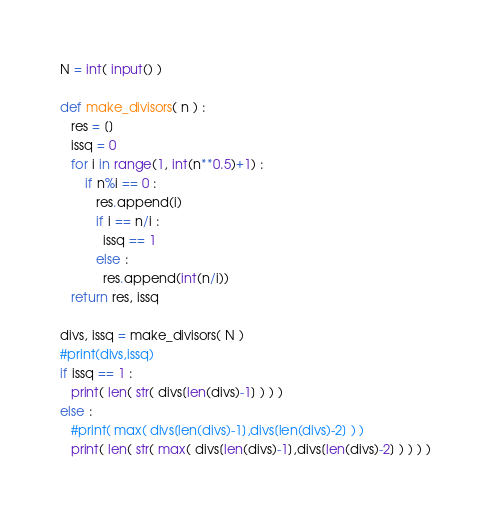Convert code to text. <code><loc_0><loc_0><loc_500><loc_500><_Python_>N = int( input() )

def make_divisors( n ) :
   res = []
   issq = 0
   for i in range(1, int(n**0.5)+1) :
       if n%i == 0 :
          res.append(i)
          if i == n/i :
            issq == 1
          else :
            res.append(int(n/i))
   return res, issq

divs, issq = make_divisors( N )
#print(divs,issq)
if issq == 1 :
   print( len( str( divs[len(divs)-1] ) ) )
else :
   #print( max( divs[len(divs)-1],divs[len(divs)-2] ) )
   print( len( str( max( divs[len(divs)-1],divs[len(divs)-2] ) ) ) )</code> 